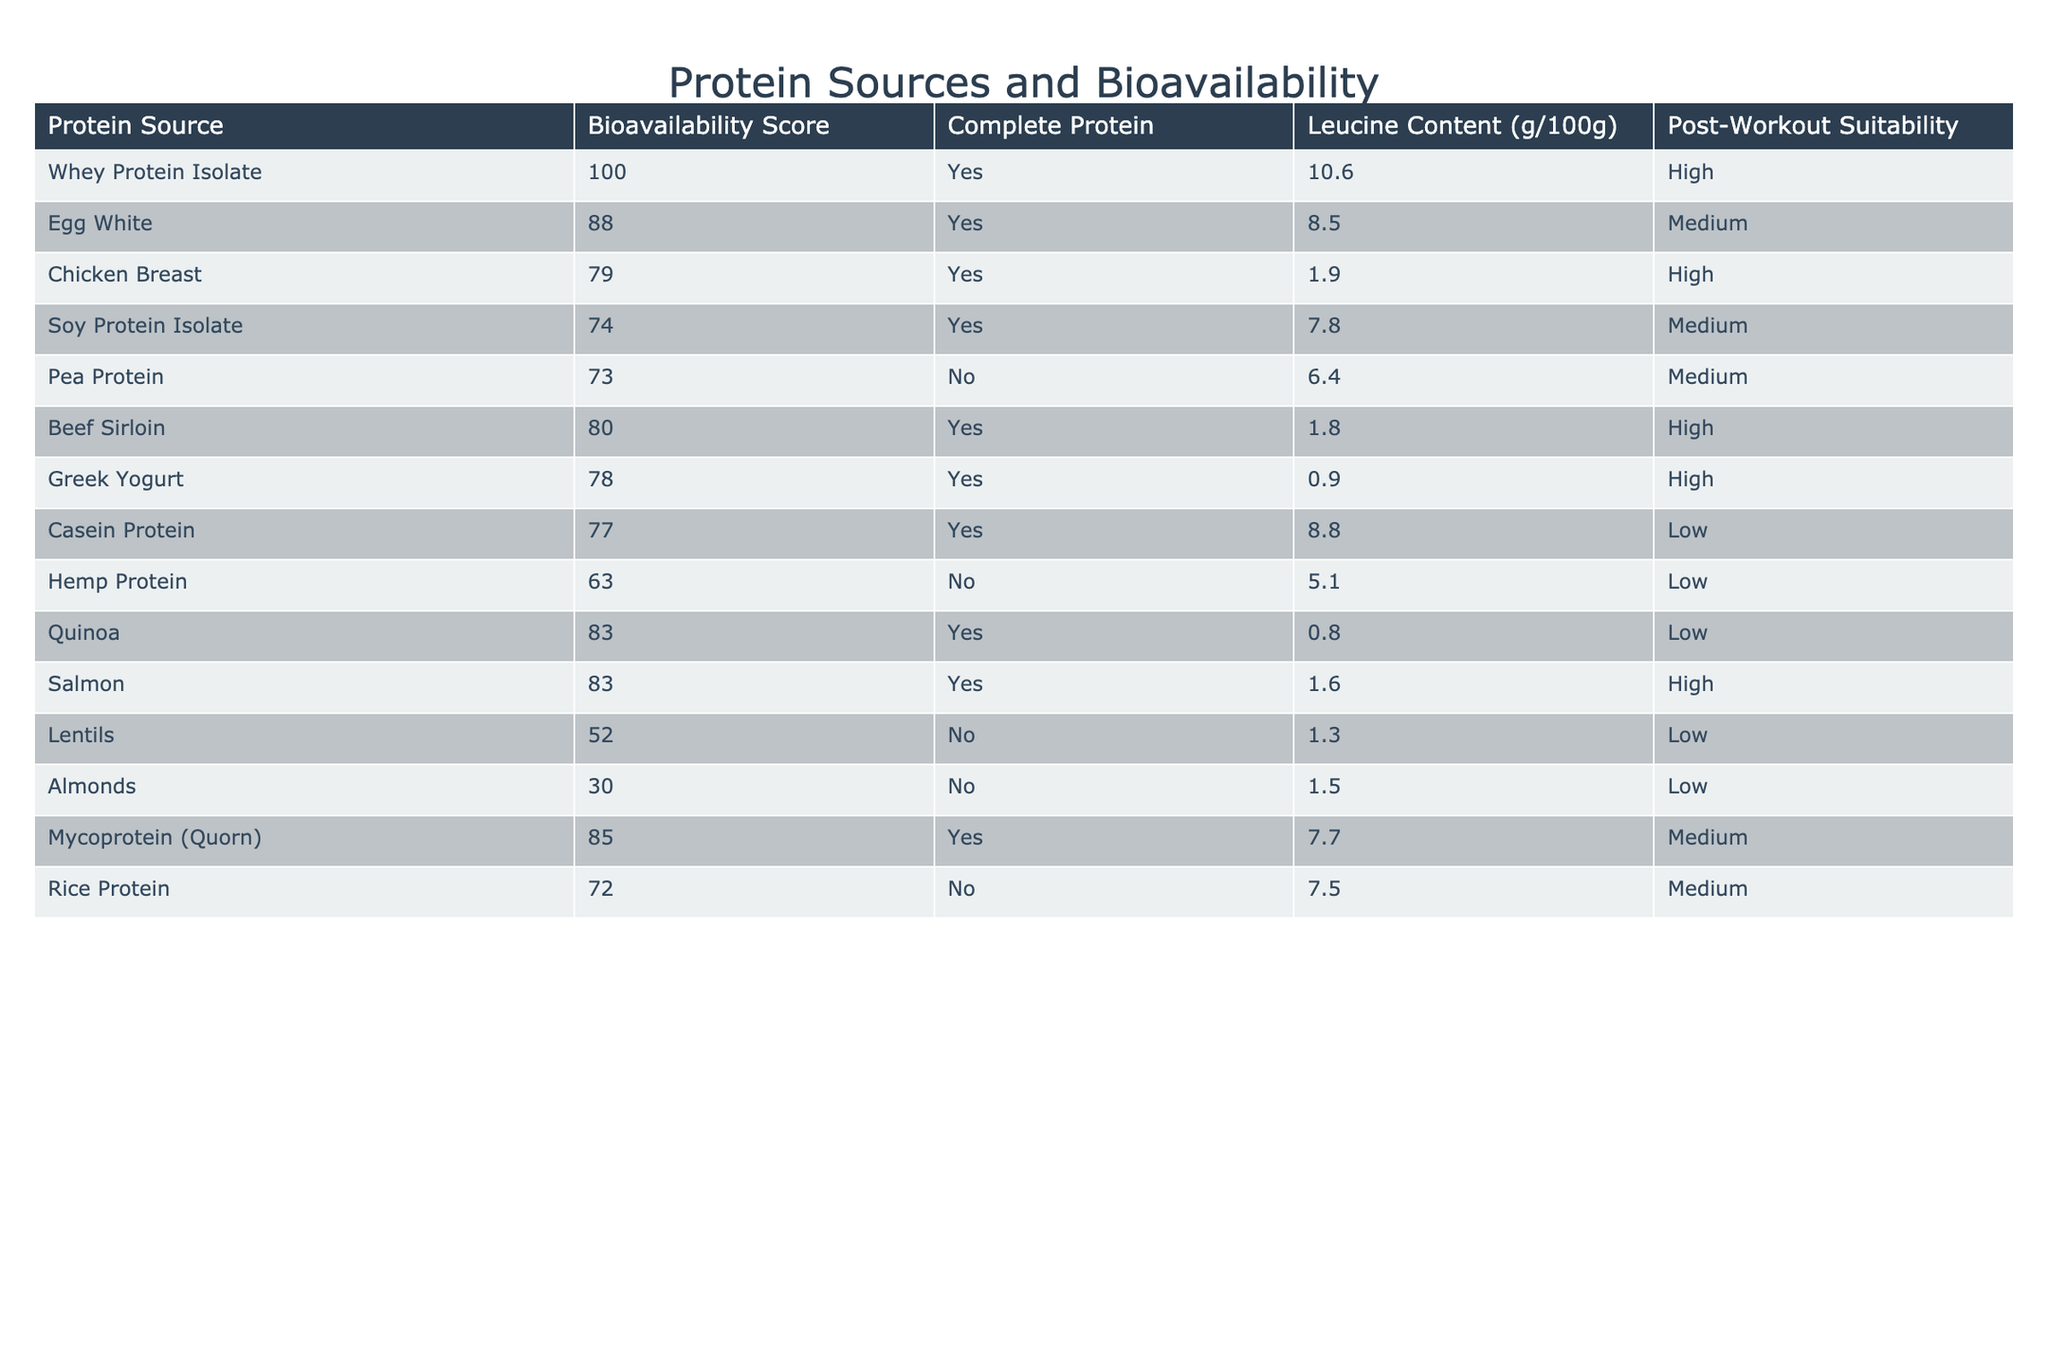What is the bioavailability score of Whey Protein Isolate? The table lists the bioavailability score of Whey Protein Isolate in the second column, which shows it as 100.
Answer: 100 Is Egg White a complete protein source? The table indicates whether a protein source is a complete protein in the third column. Egg White is marked as "Yes."
Answer: Yes Which protein source has the highest leucine content? By examining the leucine content column, Whey Protein Isolate has the highest value of 10.6 g/100g.
Answer: Whey Protein Isolate What is the post-workout suitability of Casein Protein? In the table, Casein Protein's entry shows it has a post-workout suitability marked as "Low."
Answer: Low Is Salmon a complete protein source? The third column indicates that Salmon is listed as a complete protein source with a "Yes" response.
Answer: Yes What is the average bioavailability score of protein sources listed as "High" for post-workout suitability? The protein sources with "High" suitability are Whey Protein Isolate (100), Chicken Breast (79), Beef Sirloin (80), Greek Yogurt (78), and Salmon (83). Their average is (100 + 79 + 80 + 78 + 83) / 5 = 84.
Answer: 84 How many protein sources in the table are classified as "Low" for post-workout suitability? Review the table and count the instances marked as "Low" for post-workout suitability; they are Casein Protein, Hemp Protein, Lentils, Almonds, and Quinoa, totaling five sources.
Answer: 5 Which protein source has the lowest bioavailability score and is not a complete protein? From the table, Lentils have the lowest bioavailability score of 52 and is marked as "No" for complete protein.
Answer: Lentils What is the total leucine content from all the complete protein sources? First, gather the leucine content from complete protein sources: Whey Protein Isolate (10.6), Egg White (8.5), Chicken Breast (1.9), Beef Sirloin (1.8), Greek Yogurt (0.9), Casein Protein (8.8), and Quinoa (0.8), summing up gives 10.6 + 8.5 + 1.9 + 1.8 + 0.9 + 8.8 + 0.8 = 32.3 g/100g.
Answer: 32.3 g/100g What is the relationship between bioavailability scores and post-workout suitability for the protein sources? Review the table to note that higher bioavailability scores generally align with "High" post-workout suitability, as seen with Whey Protein Isolate, Chicken Breast, and Beef Sirloin.
Answer: Higher scores often indicate "High" suitability 